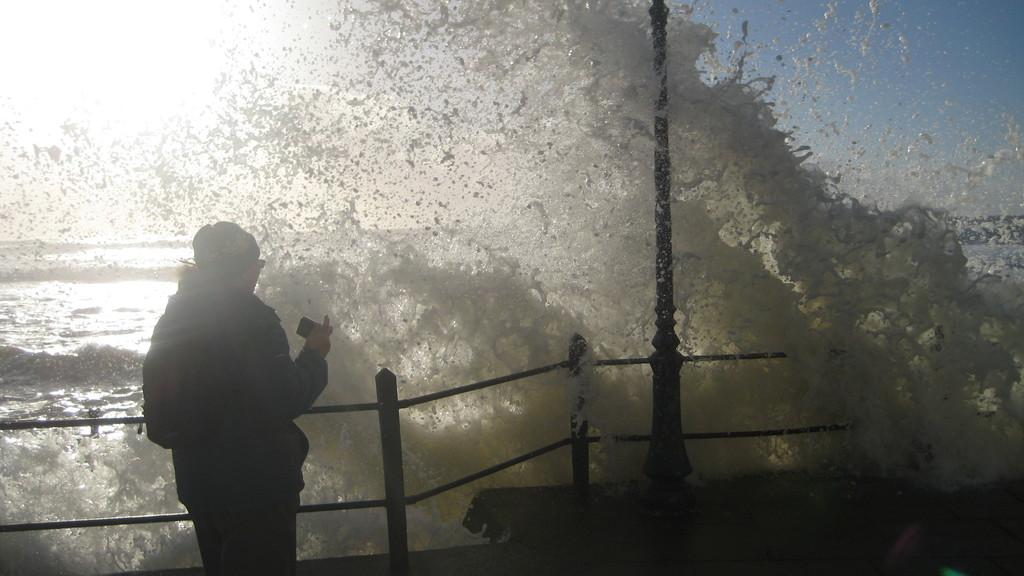What can be seen on the left side of the image? There is a lady on the left side of the image. What is the lady holding in the image? The lady is holding something. Can you describe the lady's attire in the image? The lady is wearing a cap. What architectural features are present in the image? There is a railing and a pole in the image. What natural element is visible in the image? There is water visible in the image. Can you tell me how many fish are swimming in the water in the image? There are no fish visible in the image; it only shows water. What type of bean is growing on the lady's cap in the image? There is no bean present on the lady's cap in the image. 